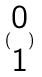<formula> <loc_0><loc_0><loc_500><loc_500>( \begin{matrix} 0 \\ 1 \end{matrix} )</formula> 